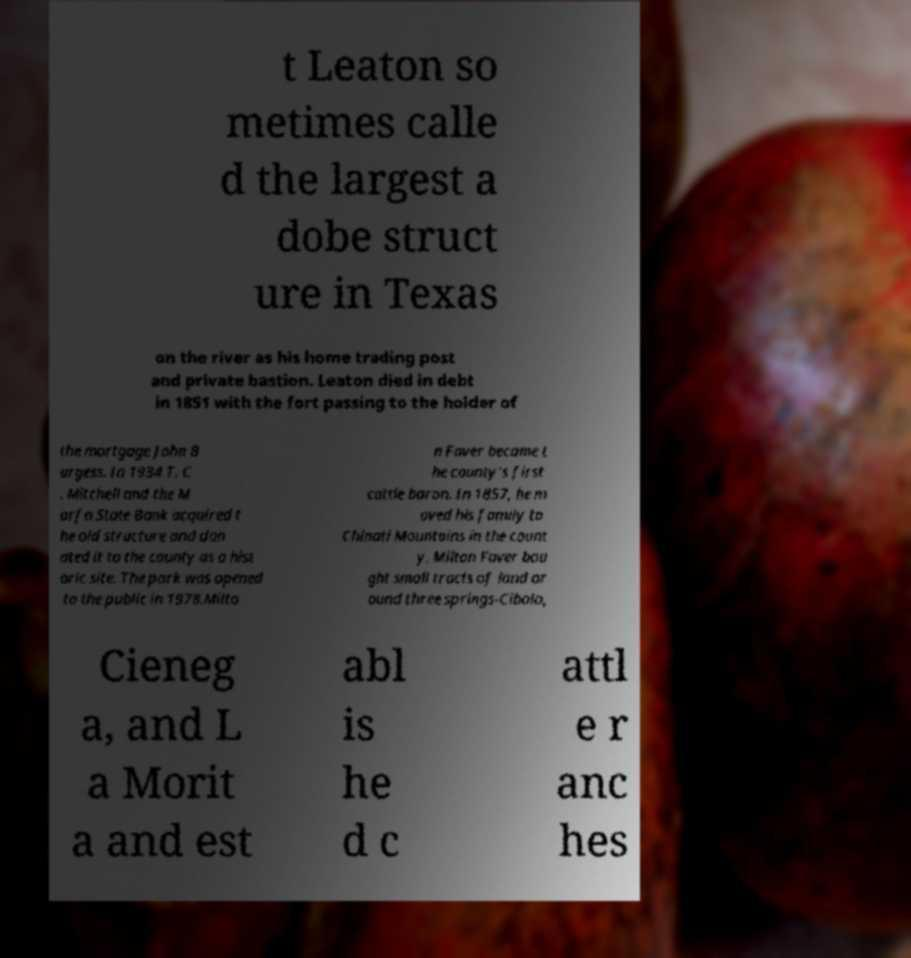Please identify and transcribe the text found in this image. t Leaton so metimes calle d the largest a dobe struct ure in Texas on the river as his home trading post and private bastion. Leaton died in debt in 1851 with the fort passing to the holder of the mortgage John B urgess. In 1934 T. C . Mitchell and the M arfa State Bank acquired t he old structure and don ated it to the county as a hist oric site. The park was opened to the public in 1978.Milto n Faver became t he county's first cattle baron. In 1857, he m oved his family to Chinati Mountains in the count y. Milton Faver bou ght small tracts of land ar ound three springs-Cibolo, Cieneg a, and L a Morit a and est abl is he d c attl e r anc hes 